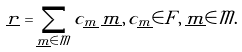<formula> <loc_0><loc_0><loc_500><loc_500>\underline { r } = \sum _ { \underline { m } \in { \mathcal { M } } } c _ { \underline { m } } \, \underline { m } , \, c _ { \underline { m } } \in F , \, \underline { m } \in { \mathcal { M } } .</formula> 